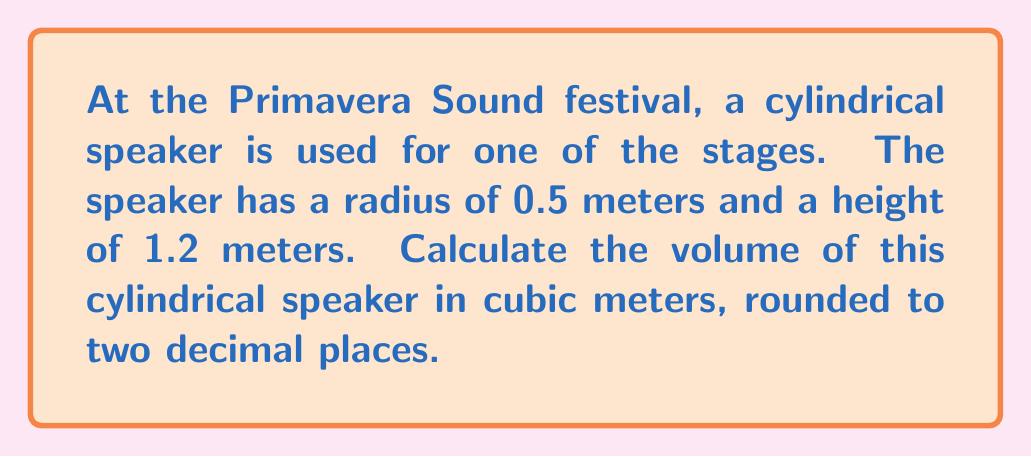Show me your answer to this math problem. To solve this problem, we need to use the formula for the volume of a cylinder:

$$V = \pi r^2 h$$

Where:
$V$ = volume of the cylinder
$\pi$ = pi (approximately 3.14159)
$r$ = radius of the base
$h$ = height of the cylinder

Given:
$r = 0.5$ meters
$h = 1.2$ meters

Let's substitute these values into the formula:

$$V = \pi (0.5)^2 (1.2)$$

Now, let's calculate step by step:

1) First, calculate $r^2$:
   $$(0.5)^2 = 0.25$$

2) Multiply by $\pi$:
   $$\pi (0.25) \approx 0.7853981634$$

3) Multiply by the height:
   $$0.7853981634 \times 1.2 \approx 0.9424777961$$

4) Round to two decimal places:
   $$0.94 \text{ m}^3$$

Therefore, the volume of the cylindrical speaker is approximately 0.94 cubic meters.

[asy]
import geometry;

size(200);
real r = 0.5;
real h = 1.2;
draw(cylinder((0,0,0),r,h),blue);
draw(circle((0,0,0),r),blue);
draw((r,0,0)--(r,0,h),dashed);
draw((0,0,0)--(r,0,0),Arrow);
draw((r,0,0)--(r,0,h),Arrow);
label("r",(r/2,0,0),E);
label("h",(r,0,h/2),E);
[/asy]
Answer: $0.94 \text{ m}^3$ 